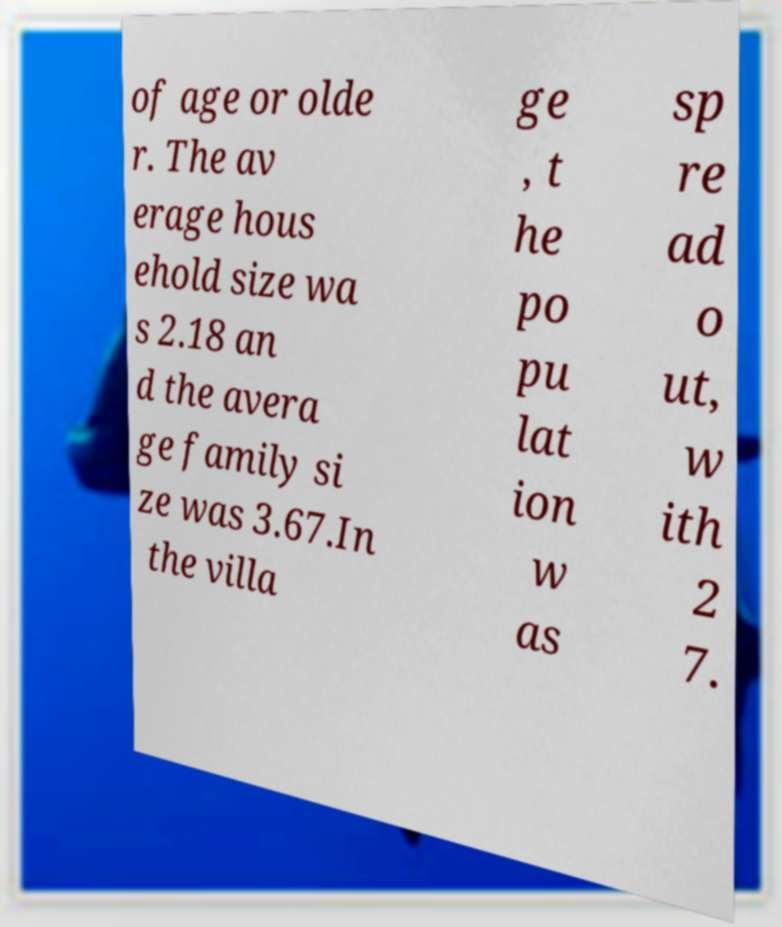For documentation purposes, I need the text within this image transcribed. Could you provide that? of age or olde r. The av erage hous ehold size wa s 2.18 an d the avera ge family si ze was 3.67.In the villa ge , t he po pu lat ion w as sp re ad o ut, w ith 2 7. 